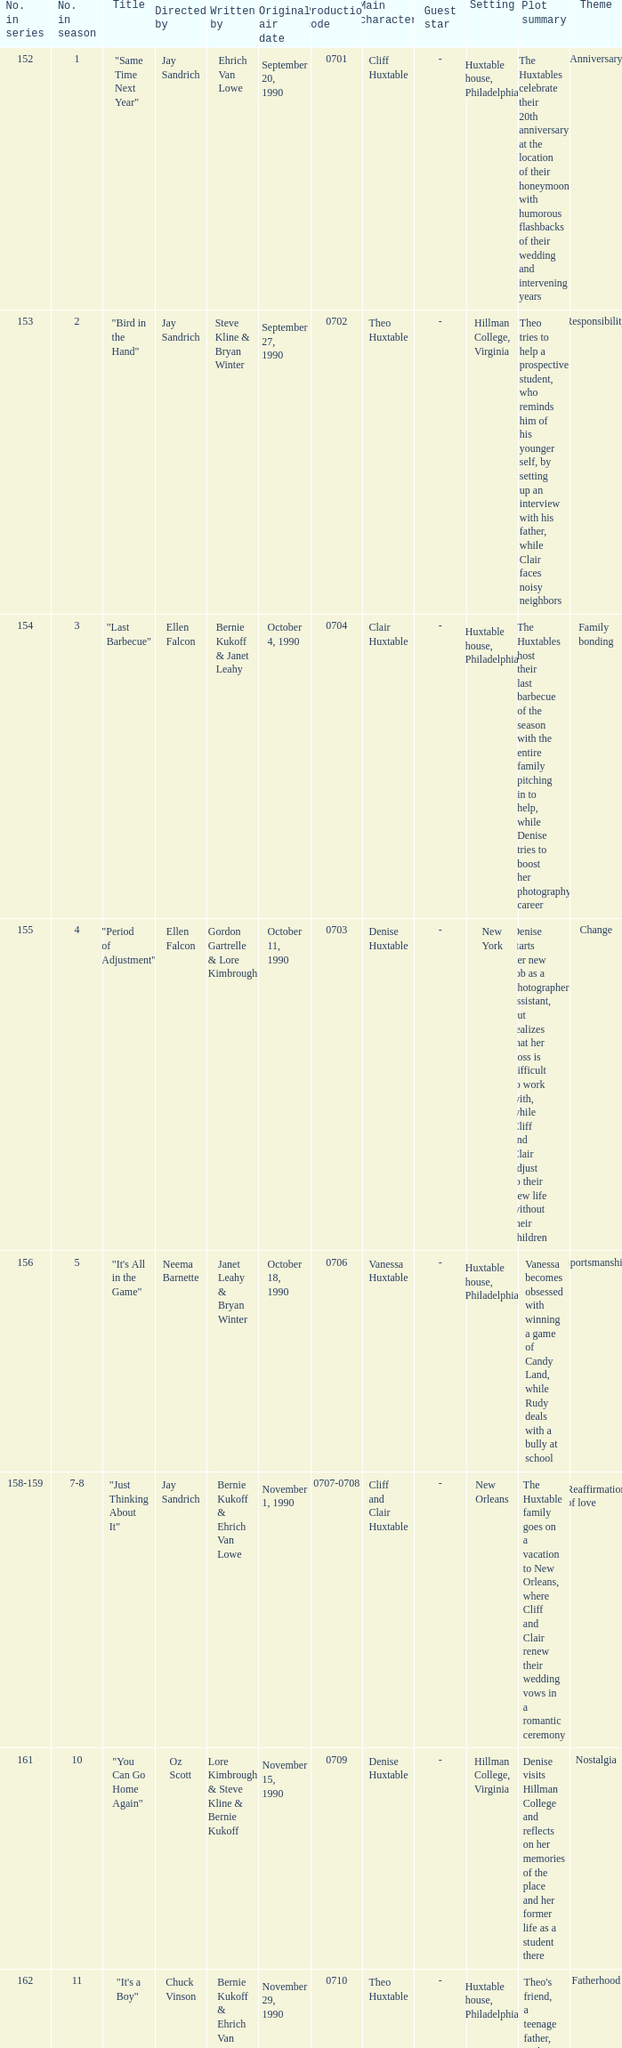In the series, which episode number was directed by art dielhenn? 166.0. 